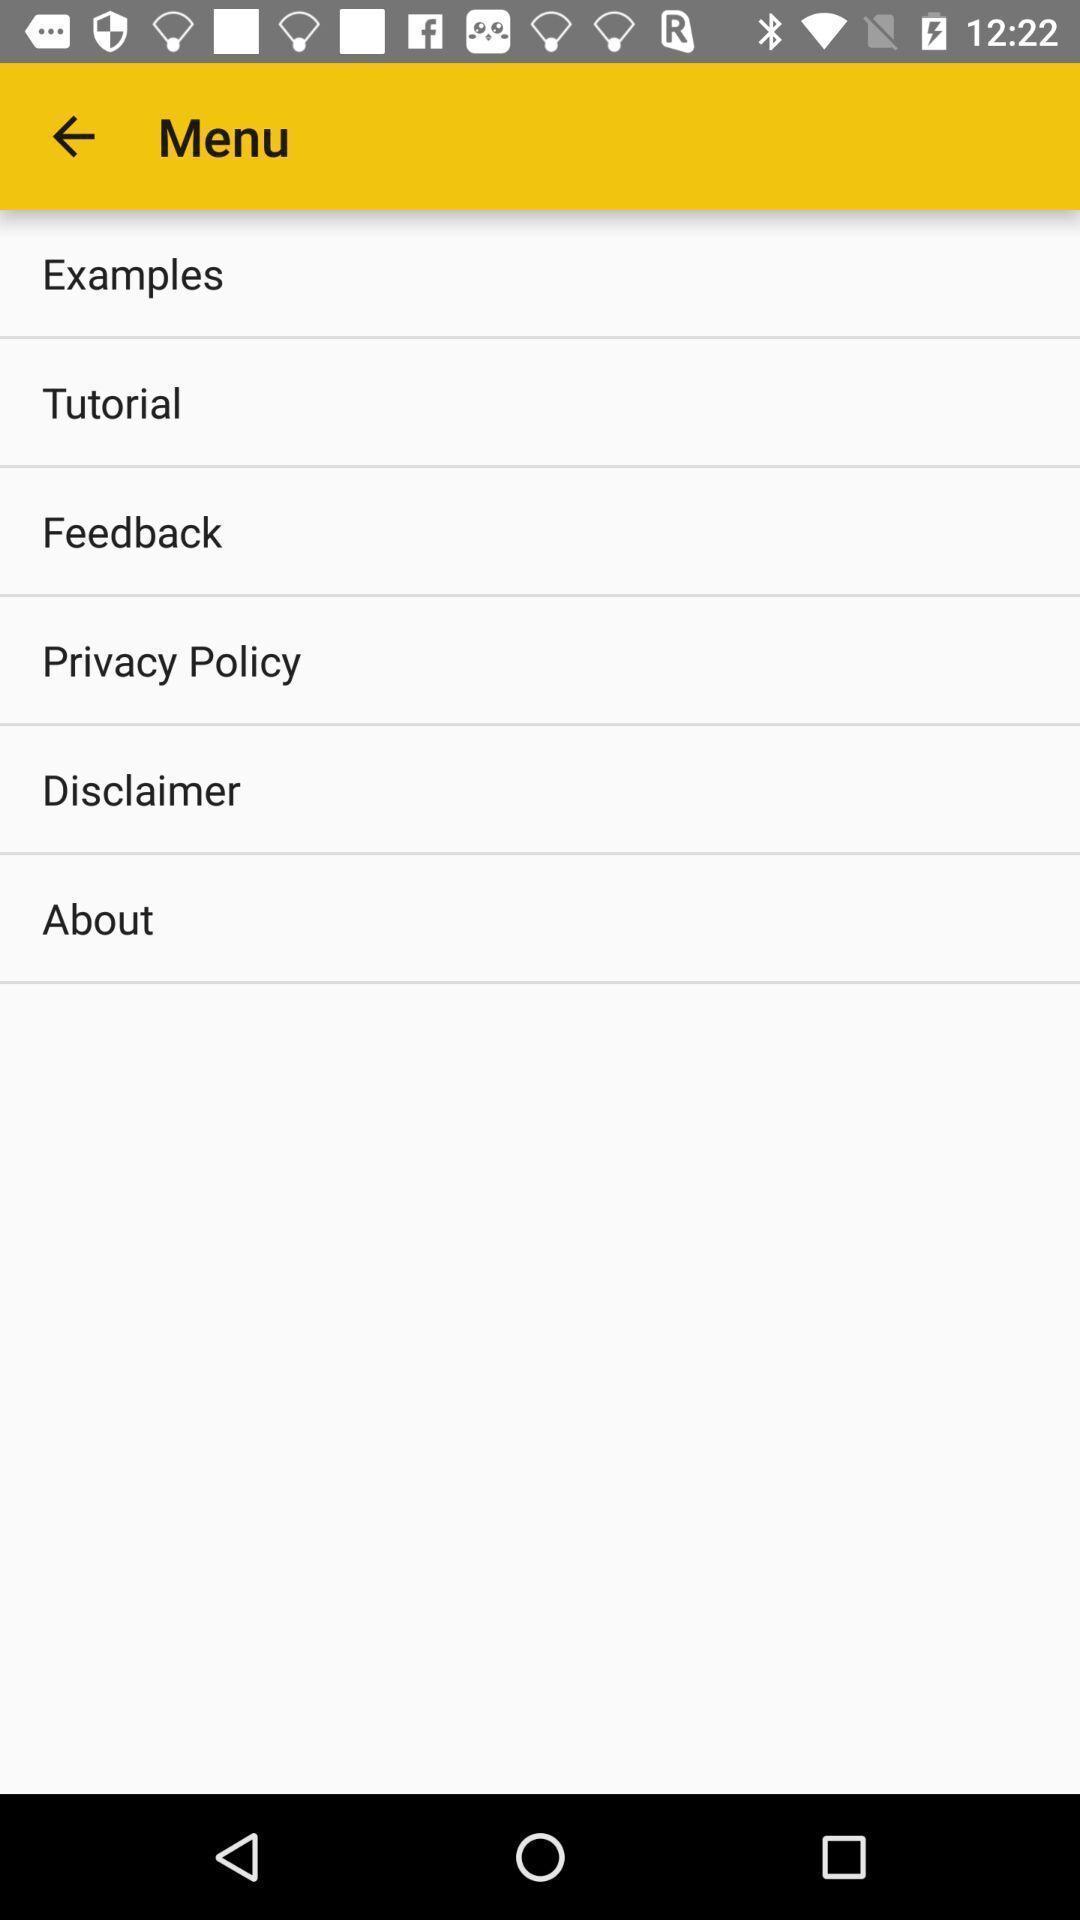Summarize the main components in this picture. Screen displaying menu of options. 